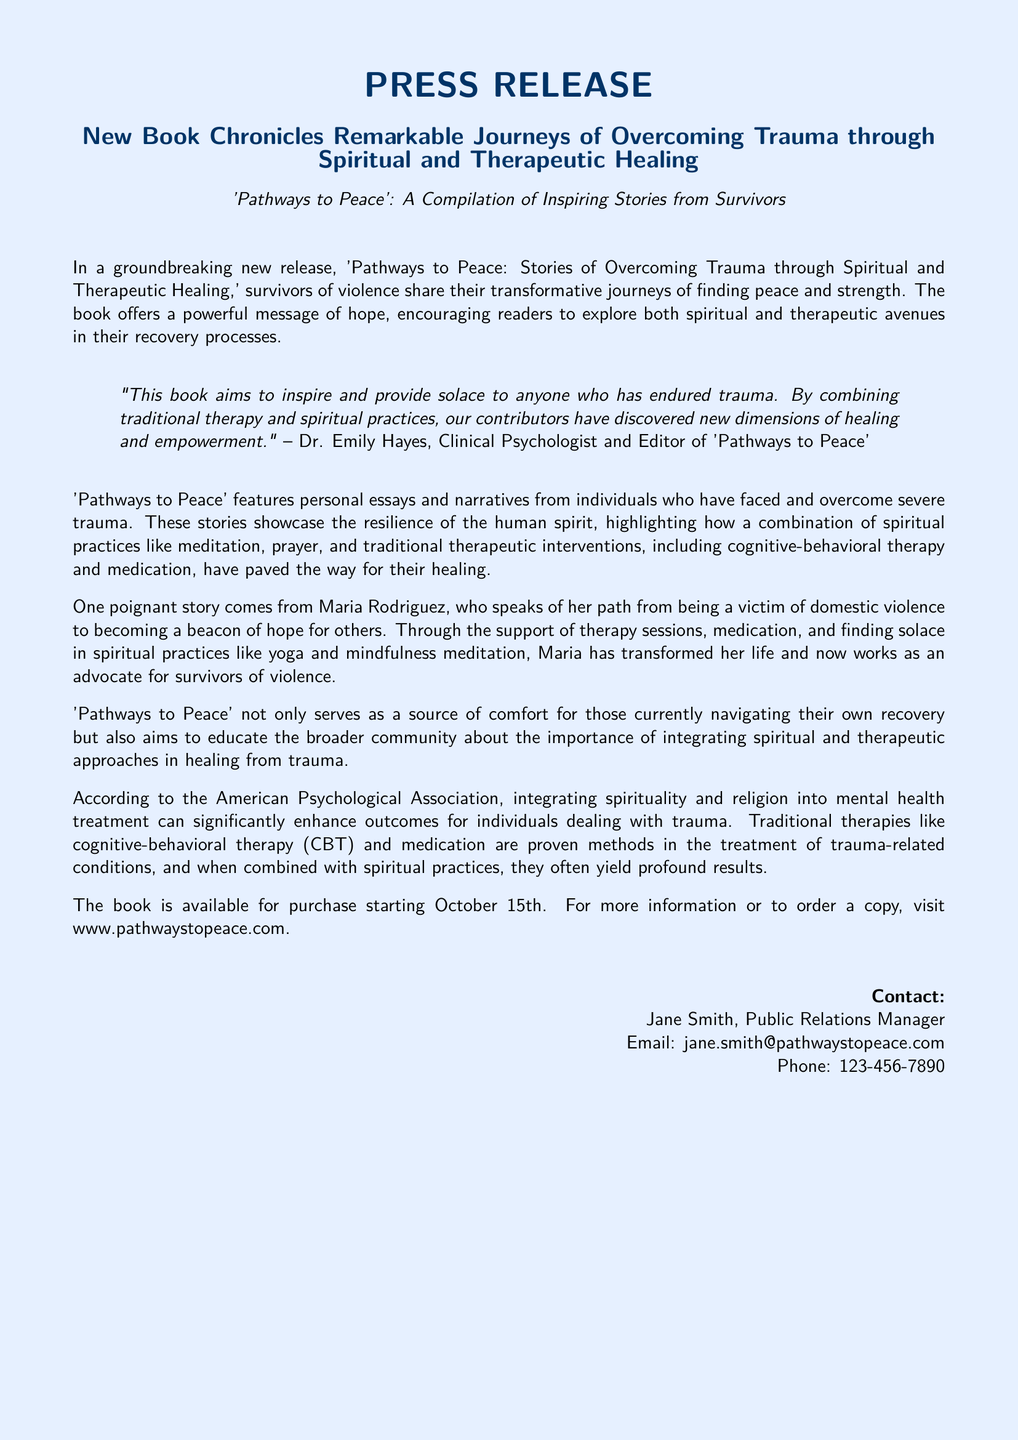What is the title of the book? The title of the book is explicitly mentioned in the document.
Answer: Pathways to Peace: Stories of Overcoming Trauma through Spiritual and Therapeutic Healing Who is the editor of the book? The editor of the book is noted in a quote within the document.
Answer: Dr. Emily Hayes What key date is mentioned for the book's availability? The document states a specific release date for purchasing the book.
Answer: October 15th Which personal story is highlighted in the document? A specific individual's story is emphasized in the text.
Answer: Maria Rodriguez What practices are combined for healing according to the book? The document refers to specific practices that aid in healing from trauma.
Answer: Meditation, prayer, cognitive-behavioral therapy, and medication What is the main goal of 'Pathways to Peace'? The document outlines the primary objective of the book in its introduction.
Answer: To inspire and provide solace to anyone who has endured trauma How does the American Psychological Association view the integration of spirituality in treatment? The document refers to a perspective from a reputable organization regarding treatment.
Answer: It can significantly enhance outcomes for individuals dealing with trauma What is the role of Maria Rodriguez after her recovery? The document describes her position post-recovery.
Answer: Advocate for survivors of violence 